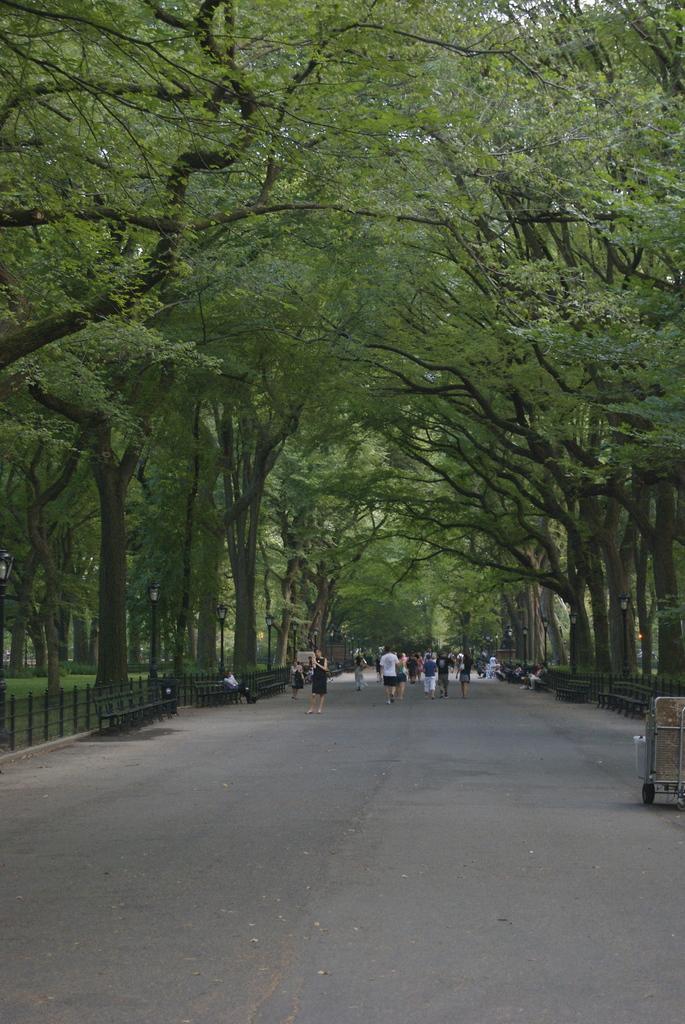How would you summarize this image in a sentence or two? This image is taken outdoors. At the bottom of the image there is a road. In the background there are many trees. On the left and right sides of the image there are two fencing's and there are a few empty benches on the road. In the middle of the image a few people are walking on the road. On the right side of the image there is a trolley on the road. 